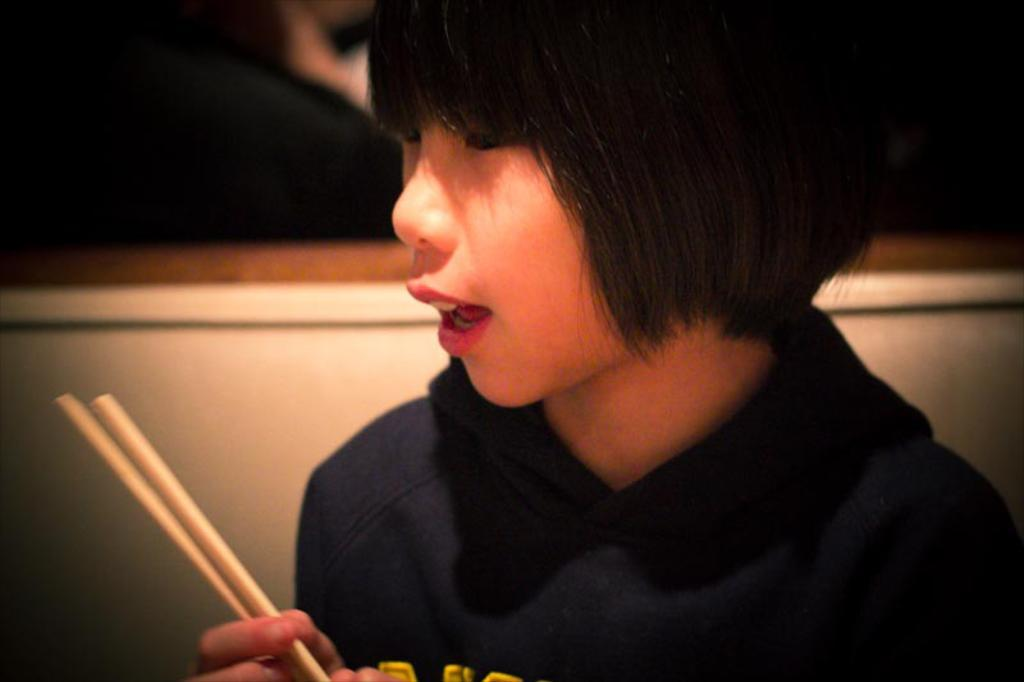What is the person in the image doing? The person is sitting in a chair and holding sticks. What might the person be doing with the sticks? It is unclear from the image what the person might be doing with the sticks. What is the person's facial expression or action? The person's mouth is open. What can be seen in the background of the image? There is a dark part in the background of the image. What type of pickle is the person holding in the image? There is no pickle present in the image. What sound does the cow make in the image? There is no cow present in the image. 